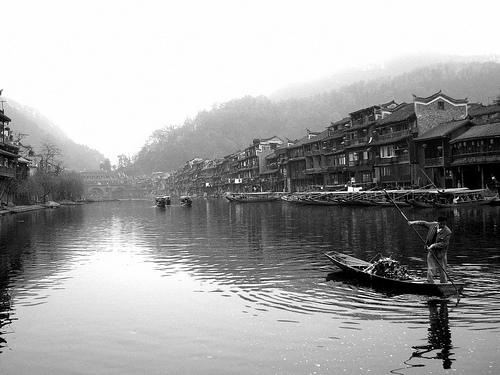Describe the scene along the riverbank in the image. Along the riverbank, there are many parked boats and attached buildings, with trees behind them. It appears to be a population near the water in a residential area. Taking into account all the information of the image, describe how the man is traveling on a boat. The man is traveling on a boat using a long paddle to row, wearing a suit and a jacket, creating ripples as he advances in the murky river towards the parked boats. Analyze the object interactions concerning the primary subject, the man in the image. The man is interacting with various objects, such as the boat he is traveling on, the long paddle he uses to row, and water with ripples and reflections formed as he moves through the river. Describe the state of the river and the surrounding vegetation. The river is large and murky; the water appears calm and still in some areas, with ripples and waves in others. There is a forest on a hillside and a tree with no leaves near the water. Count the number of boats in the image and describe what they are doing. There are 4 boats in the image: a man is rowing one of the boats, the other three boats are parked on the water, and coming towards the man in a murky river. Examine the ripples and reflections in the image and explain their significance. The ripples and light reflections on the water create interesting patterns and movement in the image, while reflections on the water also show the presence of a human. Comment on the image's color and analyze how it might impact the overall feel of the image. The image is in black and white, which can make the scene appear timeless, moody, and atmospheric, while highlighting interesting patterns, contrasts, and textures. What is the weather like in the image and how does it affect the overall sentiment of the image? The weather is overcast with a hazy sky, which gives the black and white image a moody and atmospheric sentiment. Point out any unique characteristics of the landscape or the location in the image. The image shows a residential area along a river, with houses and buildings on the waterfront and a bridge over the river. The landscape has a combination of water, built environment, and trees. Discuss the appearance of the buildings situated along the river. The buildings along the river are attached, appearing as homes on the waterfront with lights near them. There are houses on both the right and left sides of the river. Which caption best describes the image color? a) Vivid and colorful b) Black and white c) Sepia-toned b) Black and white Compose a vivid description of the river considering its color and state. The murky water of the river, filled with ripples, weaves a silver thread among the houses and boats as it reflects the sky above. Does the man on the boat wear a jacket and pants or a swimsuit? The man wears a jacket and pants, possibly a suit. Describe the architecture of the buildings shown in the image. The buildings are attached row houses in a straight line. How many boats are approaching the man on the rowboat? Three boats are coming towards the man. Do the buildings in the image appear to be attached or detached? The buildings are attached. Is the sky in the image clear or overcast? The sky is overcast and cloudy. Regarding the lights near the building, are they reflected on the water or only visible near the building? The lights are reflected on the water. Is the man on the boat holding a paddle or an umbrella? The man is holding a paddle. What is the state of the water in the river? The water is murky and has lots of ripples. Identify the emotions displayed by the man in the boat. Is he happy, sad, or neutral? Neutral, as there is not enough facial information available. Select the best description of the condition of the water: a) calm, b) wavy, c) still. a) calm Describe the area surrounding the river in this image. There are lots of boats along the bank, buildings on the waterfront, and trees behind the buildings. How would you describe the foliage of the tree in the image? A tree with no leaves. Describe the general shape and height of the tree in the scene. A tall, thin tree with a straight trunk and no leaves. What is the predominant element of the scenery in the background? A forest on a hillside. Create a poetic description of the scene depicted in the image. Hazy sky cloaking a black and white world, where boats glide with silent purpose 'pon reflective waters, framed by a forest upon the hillside and buildings on the shore. Do the parked boats belong to a group or are they randomly parked? The boats belong to a group. In the image, is the man on a boat or on a dock? The man is on a boat. What activity is the man doing on the boat? The man is rowing the boat. 